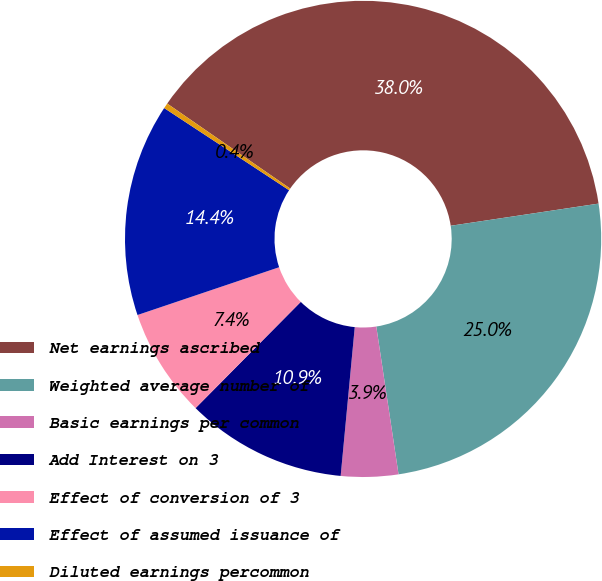<chart> <loc_0><loc_0><loc_500><loc_500><pie_chart><fcel>Net earnings ascribed<fcel>Weighted average number of<fcel>Basic earnings per common<fcel>Add Interest on 3<fcel>Effect of conversion of 3<fcel>Effect of assumed issuance of<fcel>Diluted earnings percommon<nl><fcel>38.01%<fcel>24.99%<fcel>3.88%<fcel>10.92%<fcel>7.4%<fcel>14.44%<fcel>0.36%<nl></chart> 